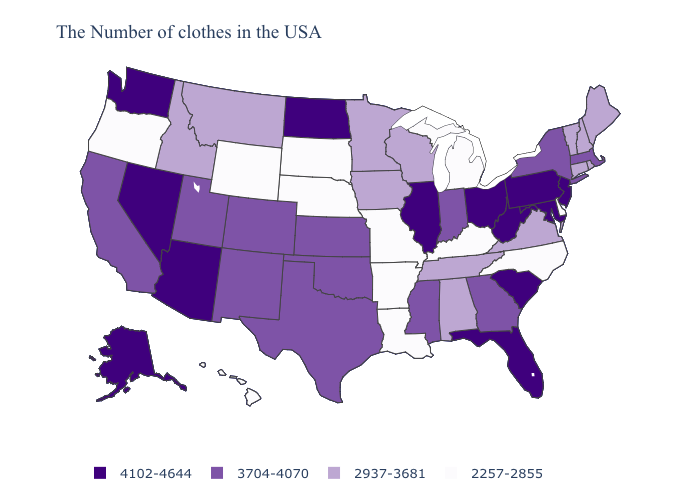Name the states that have a value in the range 4102-4644?
Write a very short answer. New Jersey, Maryland, Pennsylvania, South Carolina, West Virginia, Ohio, Florida, Illinois, North Dakota, Arizona, Nevada, Washington, Alaska. Name the states that have a value in the range 4102-4644?
Write a very short answer. New Jersey, Maryland, Pennsylvania, South Carolina, West Virginia, Ohio, Florida, Illinois, North Dakota, Arizona, Nevada, Washington, Alaska. Name the states that have a value in the range 2257-2855?
Keep it brief. Delaware, North Carolina, Michigan, Kentucky, Louisiana, Missouri, Arkansas, Nebraska, South Dakota, Wyoming, Oregon, Hawaii. Does the map have missing data?
Answer briefly. No. Among the states that border Wisconsin , which have the highest value?
Short answer required. Illinois. Name the states that have a value in the range 2257-2855?
Write a very short answer. Delaware, North Carolina, Michigan, Kentucky, Louisiana, Missouri, Arkansas, Nebraska, South Dakota, Wyoming, Oregon, Hawaii. What is the value of Maryland?
Concise answer only. 4102-4644. Among the states that border Connecticut , which have the lowest value?
Quick response, please. Rhode Island. What is the value of New Jersey?
Be succinct. 4102-4644. Is the legend a continuous bar?
Quick response, please. No. Name the states that have a value in the range 3704-4070?
Write a very short answer. Massachusetts, New York, Georgia, Indiana, Mississippi, Kansas, Oklahoma, Texas, Colorado, New Mexico, Utah, California. Is the legend a continuous bar?
Quick response, please. No. What is the highest value in states that border Nebraska?
Short answer required. 3704-4070. Name the states that have a value in the range 4102-4644?
Give a very brief answer. New Jersey, Maryland, Pennsylvania, South Carolina, West Virginia, Ohio, Florida, Illinois, North Dakota, Arizona, Nevada, Washington, Alaska. What is the value of Kentucky?
Write a very short answer. 2257-2855. 